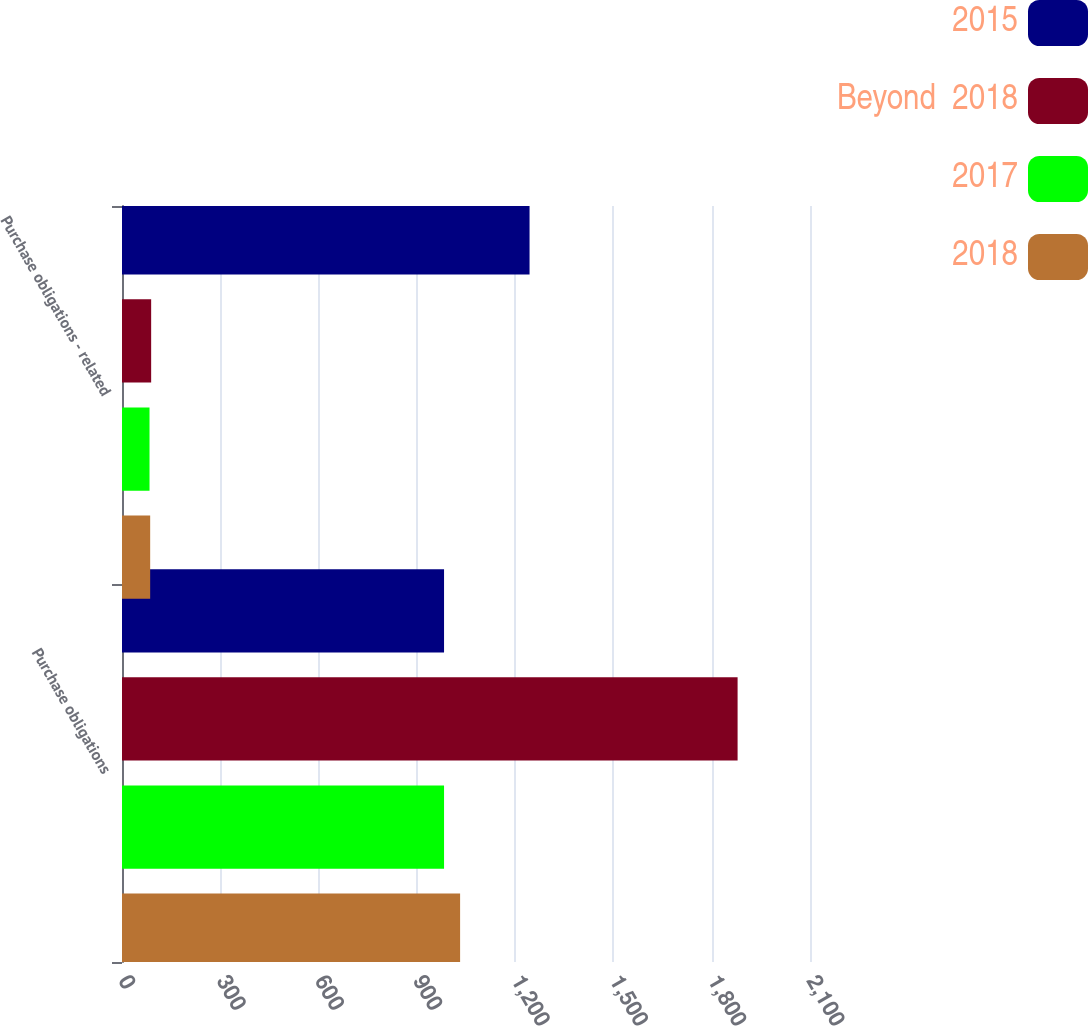Convert chart. <chart><loc_0><loc_0><loc_500><loc_500><stacked_bar_chart><ecel><fcel>Purchase obligations<fcel>Purchase obligations - related<nl><fcel>2015<fcel>983<fcel>1244<nl><fcel>Beyond  2018<fcel>1879<fcel>89<nl><fcel>2017<fcel>983<fcel>84<nl><fcel>2018<fcel>1032<fcel>86<nl></chart> 